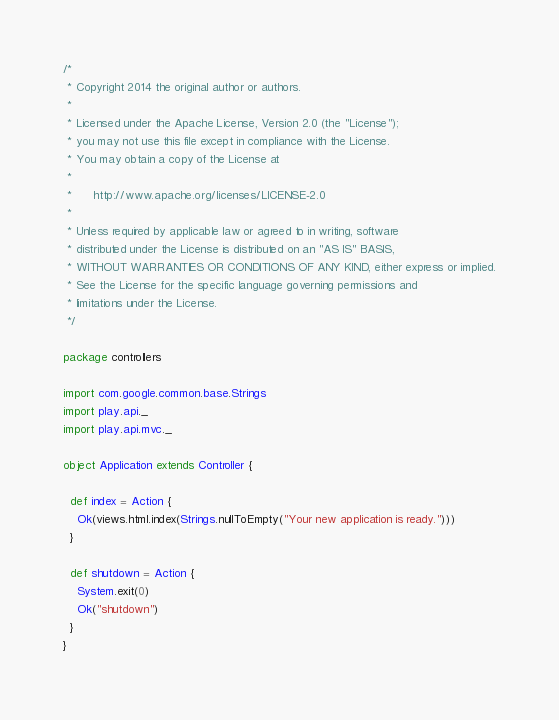<code> <loc_0><loc_0><loc_500><loc_500><_Scala_>/*
 * Copyright 2014 the original author or authors.
 *
 * Licensed under the Apache License, Version 2.0 (the "License");
 * you may not use this file except in compliance with the License.
 * You may obtain a copy of the License at
 *
 *      http://www.apache.org/licenses/LICENSE-2.0
 *
 * Unless required by applicable law or agreed to in writing, software
 * distributed under the License is distributed on an "AS IS" BASIS,
 * WITHOUT WARRANTIES OR CONDITIONS OF ANY KIND, either express or implied.
 * See the License for the specific language governing permissions and
 * limitations under the License.
 */

package controllers

import com.google.common.base.Strings
import play.api._
import play.api.mvc._

object Application extends Controller {

  def index = Action {
    Ok(views.html.index(Strings.nullToEmpty("Your new application is ready.")))
  }

  def shutdown = Action {
    System.exit(0)
    Ok("shutdown")
  }
}</code> 